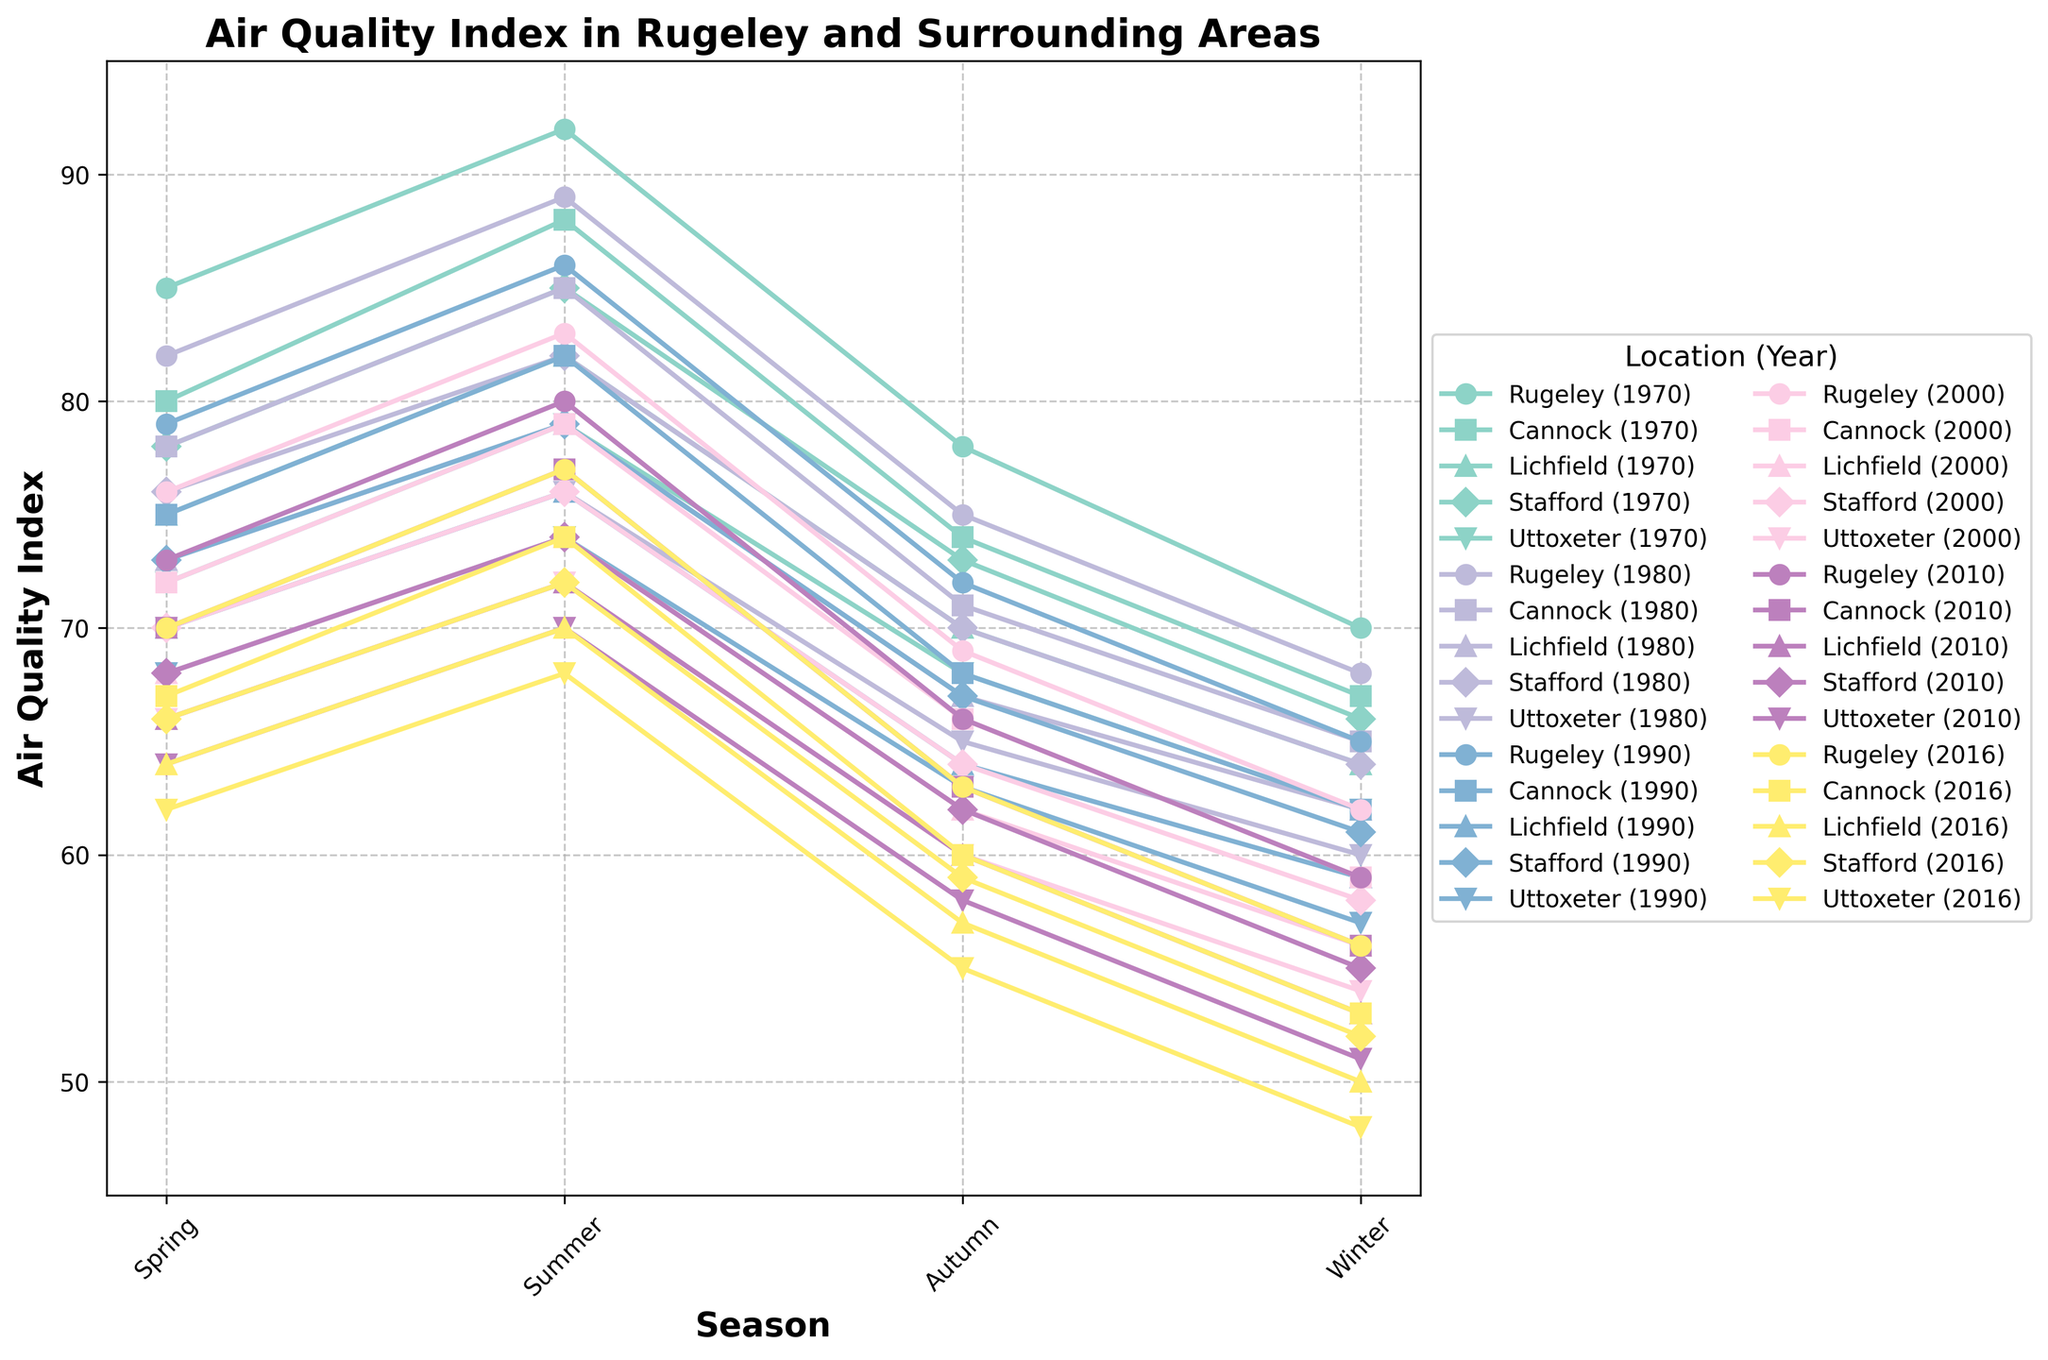What was the air quality index in Rugeley during the summer of 1970? To find this, look at the curve labeled 'Rugeley (1970)' and find the data point for the 'Summer' season. According to the chart, there is a data point located at around 92.
Answer: 92 How did the air quality in Rugeley change from the spring to the autumn of 1980? To answer this, observe the 'Rugeley (1980)' line for the Spring and Autumn seasons. The values are 82 (Spring) and 75 (Autumn). Calculate the difference: 82 - 75 = 7.
Answer: Decreased by 7 Which location had the highest air quality index in the winter of 2016? To find this, look at the Winter data for the year 2016 across all locations. Rugeley has an index of 56, Cannock 53, Lichfield 50, Stafford 52, and Uttoxeter 48. Rugeley's value, 56, is the highest.
Answer: Rugeley Comparing the air quality index in Lichfield, how much did it improve during the summer of 2010 compared to the winter of 2000? Look at the summer value for Lichfield in 2010, which is 72, and the winter value in 2000, which is 56. Calculate the difference: 72 - 56 = 16.
Answer: Improved by 16 What is the average air quality index for Stafford across all seasons in the year 1990? The values for Stafford in 1990 are Spring: 73, Summer: 79, Autumn: 67, Winter: 61. To find the average, sum these values and divide by 4: (73 + 79 + 67 + 61) / 4 = 70.
Answer: 70 In the autumn of 1970, which location had the poorest air quality index, and what was the value? Look at the Autumn data for 1970. The values are Rugeley: 78, Cannock: 74, Lichfield: 70, Stafford: 73, Uttoxeter: 68. Uttoxeter has the lowest value, 68.
Answer: Uttoxeter, 68 How did the air quality in Cannock change from summer 2000 to winter 2000? Observe the values for Cannock in summer 2000 (79) and winter 2000 (59). The difference is: 79 - 59 = 20, indicating a decrease.
Answer: Decreased by 20 Which year had a higher average air quality index in Rugeley, 2010, or 2016? First, calculate the average for 2010: (73+80+66+59)/4 = 69.5. Then for 2016: (70+77+63+56)/4 = 66.5. Compare the two averages, 69.5 and 66.5; 2010 is higher.
Answer: 2010 How did the air quality index in Stafford in spring of 1980 compare to the air Quality Index in Lichfield in summer of 2016? Look at Stafford in Spring 1980, which is 76, and Lichfield in Summer 2016, which is 70. Compare the values, and 76 is higher than 70.
Answer: Stafford's is higher What was the difference in air quality index between spring and winter for Rugeley in 1970? For Rugeley in 1970, the Spring index is 85, and the Winter index is 70. The difference is 85 - 70 = 15.
Answer: 15 